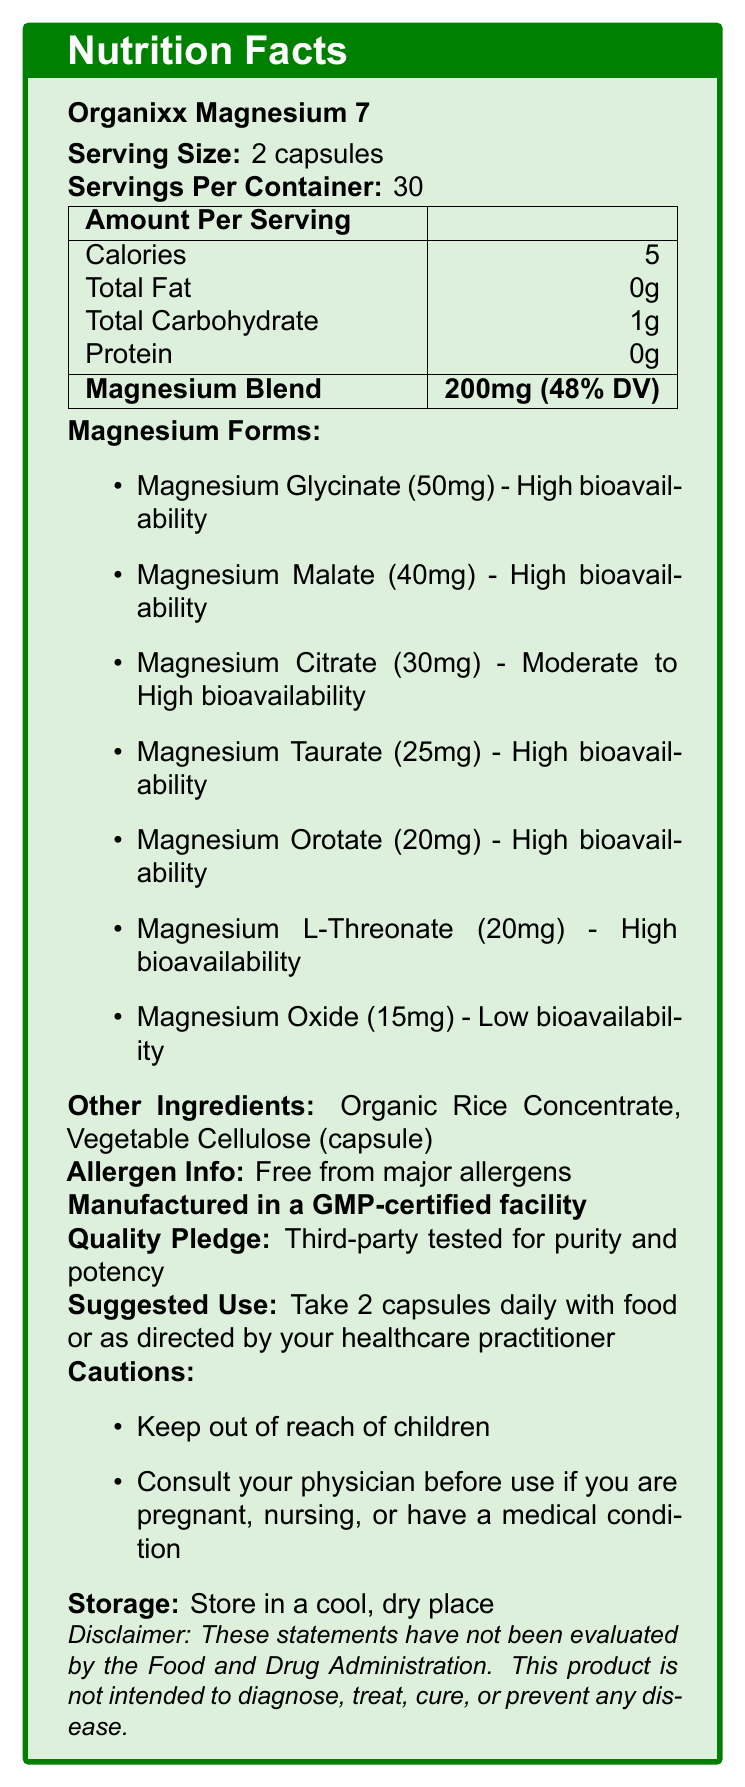what is the serving size of Organixx Magnesium 7? The document lists the serving size as "2 capsules."
Answer: 2 capsules how many calories are in one serving of Organixx Magnesium 7? The document indicates that each serving contains 5 calories.
Answer: 5 calories how much total carbohydrate is present in one serving? The Nutrition Facts indicate that the total carbohydrate per serving is 1g.
Answer: 1g how many servings are in each container of Organixx Magnesium 7? The document specifies that there are 30 servings per container.
Answer: 30 servings how much total magnesium is provided per serving? According to the document, each serving provides 200mg of total magnesium.
Answer: 200mg which form of magnesium in the blend has the highest amount per serving? The document states that Magnesium Glycinate has the highest amount with 50mg per serving.
Answer: Magnesium Glycinate which form of magnesium has the lowest bioavailability? The document indicates that Magnesium Oxide has low bioavailability.
Answer: Magnesium Oxide what ingredient is used to make the capsule? The document lists Vegetable Cellulose as an ingredient used for the capsule.
Answer: Vegetable Cellulose can this product be used by people with major allergen sensitivities? The document confirms that the product is free from major allergens.
Answer: Yes what should you do if pregnant or nursing before using this product? The document advises consulting your physician if you are pregnant, nursing, or have a medical condition.
Answer: Consult your physician what is the intended use of this product according to the document? The disclaimer states that the product is not intended to diagnose, treat, cure, or prevent any disease.
Answer: Not intended to diagnose, treat, cure, or prevent any disease which form of magnesium supports cognitive function? A. Magnesium Glycinate B. Magnesium L-Threonate C. Magnesium Citrate D. Magnesium Malate The document states that Magnesium L-Threonate supports cognitive function.
Answer: B. Magnesium L-Threonate what additional benefit does Magnesium Glycinate offer aside from its high bioavailability? A. Supports energy production B. Gentle on the stomach C. Enhances athletic performance D. Supports cardiovascular health The document indicates that Magnesium Glycinate is easily absorbed and gentle on the stomach.
Answer: B. Gentle on the stomach is Organixx Magnesium 7 made in a GMP-certified facility? The document mentions that the product is made in a GMP-certified facility.
Answer: Yes what are the storage instructions? The document advises storing the product in a cool, dry place.
Answer: Store in a cool, dry place do you take Organixx Magnesium 7 capsules with or without food? The document suggests taking the capsules with food.
Answer: With food describe the main idea of the document The document thoroughly presents the composition, benefits, and usage guidelines for Organixx Magnesium 7, emphasizing the high bioavailability of its multiple magnesium forms and ensuring product quality.
Answer: The document provides detailed Nutrition Facts for Organixx Magnesium 7, a supplement containing seven forms of magnesium designed for high bioavailability and various health benefits. It includes serving size, amounts per serving, ingredient list, allergen information, use instructions, and additional notes on quality and safety. how much protein is in one serving of Organixx Magnesium 7? The Nutrition Facts section states that there is 0g of protein per serving.
Answer: 0g how is the quality of Organixx Magnesium 7 assured? The document mentions that the product is third-party tested for purity and potency.
Answer: Third-party tested for purity and potency can Organixx Magnesium 7 be used to cure diseases? The disclaimer clearly states that this product is not intended to diagnose, treat, cure, or prevent any disease.
Answer: No what is the total number of mg of all forms of magnesium combined? The document provides individual amounts of each magnesium form but does not add up the totals; the total magnesium amount listed (200mg) is an aggregate figure that includes various forms.
Answer: Cannot be determined 